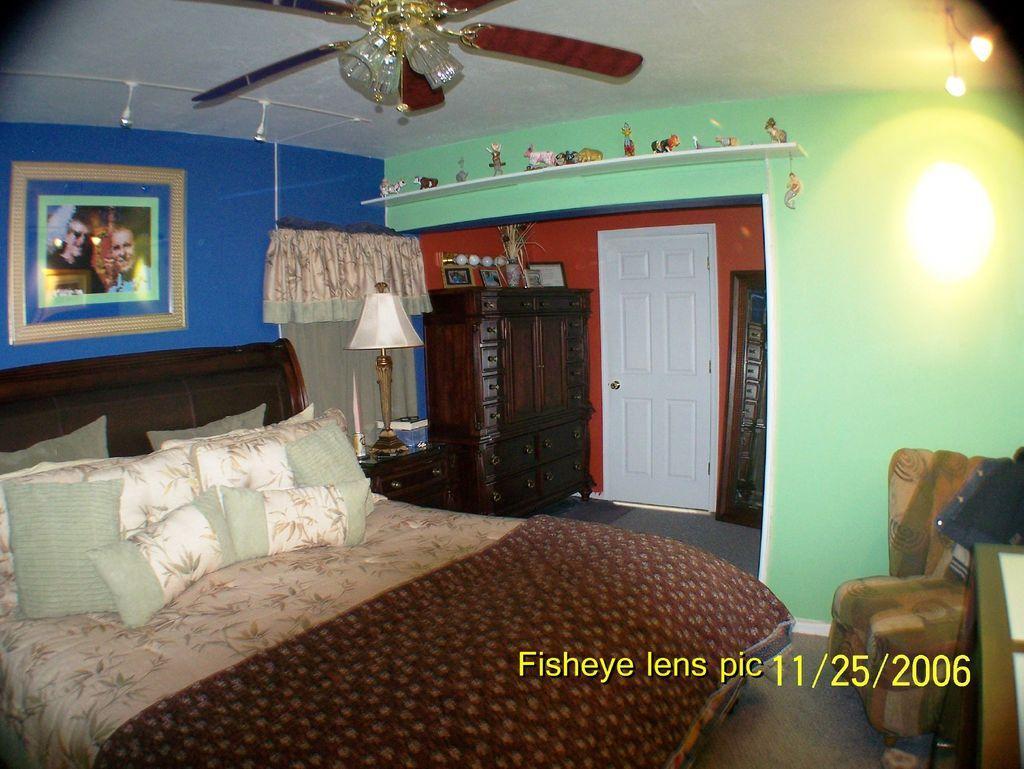Could you give a brief overview of what you see in this image? In this image inside a room there is a bed. On the bed there are few pillows. Here there is a photo frame. In the right there is a sofa. In the background there is door, cupboards, table, table lamp. Here on the stand there are many statues. Here there are lights. 